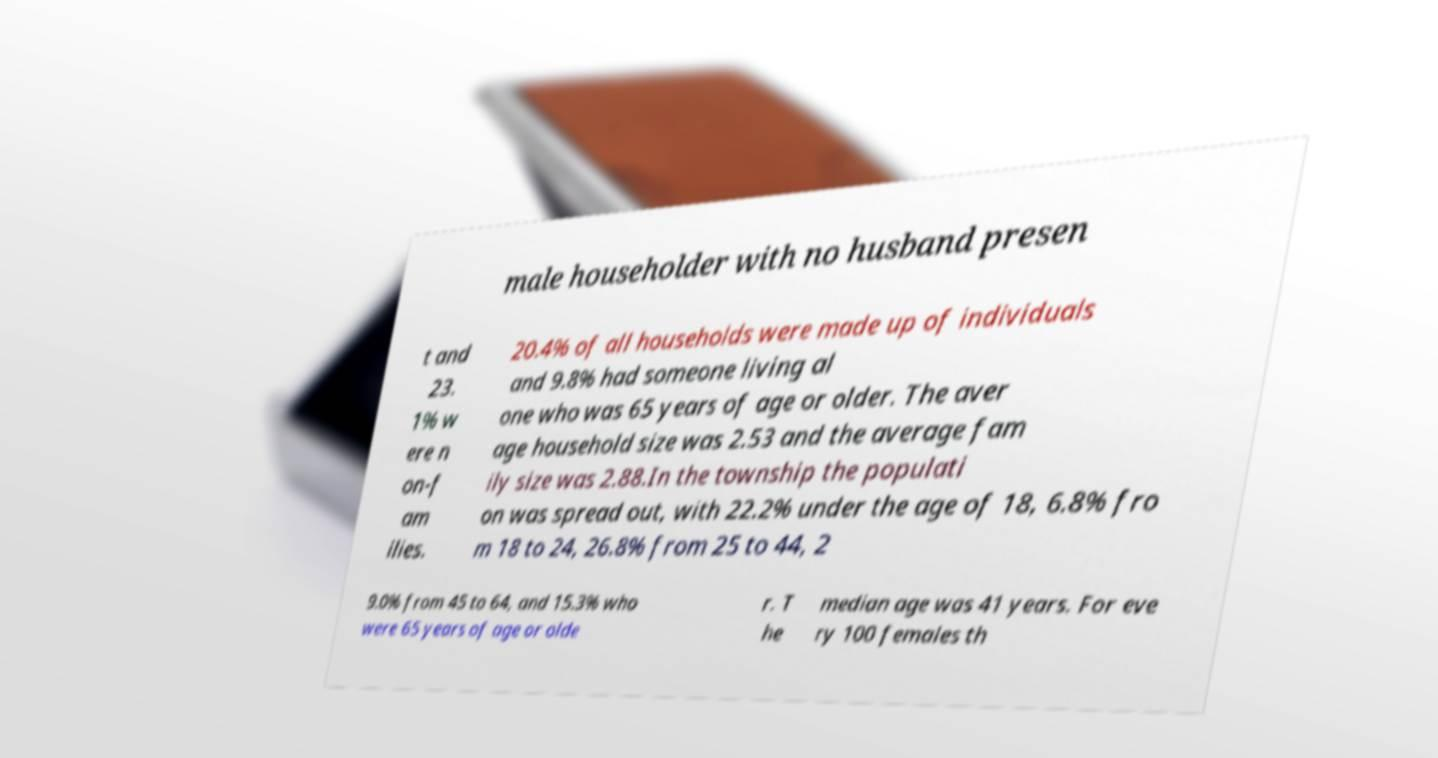Can you read and provide the text displayed in the image?This photo seems to have some interesting text. Can you extract and type it out for me? male householder with no husband presen t and 23. 1% w ere n on-f am ilies. 20.4% of all households were made up of individuals and 9.8% had someone living al one who was 65 years of age or older. The aver age household size was 2.53 and the average fam ily size was 2.88.In the township the populati on was spread out, with 22.2% under the age of 18, 6.8% fro m 18 to 24, 26.8% from 25 to 44, 2 9.0% from 45 to 64, and 15.3% who were 65 years of age or olde r. T he median age was 41 years. For eve ry 100 females th 